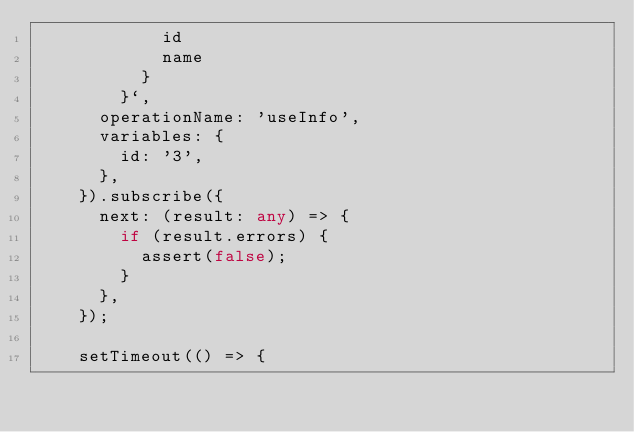<code> <loc_0><loc_0><loc_500><loc_500><_TypeScript_>            id
            name
          }
        }`,
      operationName: 'useInfo',
      variables: {
        id: '3',
      },
    }).subscribe({
      next: (result: any) => {
        if (result.errors) {
          assert(false);
        }
      },
    });

    setTimeout(() => {</code> 